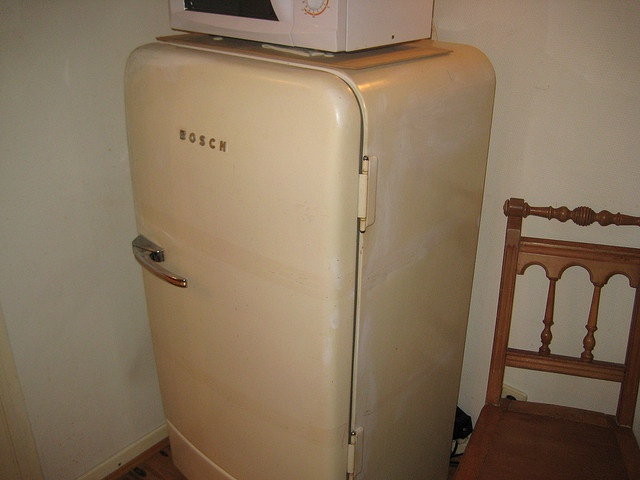Describe the objects in this image and their specific colors. I can see refrigerator in gray and tan tones, chair in gray, black, and maroon tones, and microwave in gray, darkgray, and black tones in this image. 